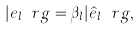Convert formula to latex. <formula><loc_0><loc_0><loc_500><loc_500>| e _ { l } \ r g = \beta _ { l } | \hat { e } _ { l } \ r g ,</formula> 